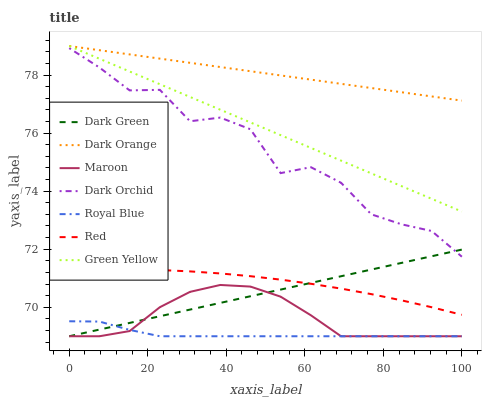Does Royal Blue have the minimum area under the curve?
Answer yes or no. Yes. Does Dark Orange have the maximum area under the curve?
Answer yes or no. Yes. Does Dark Orchid have the minimum area under the curve?
Answer yes or no. No. Does Dark Orchid have the maximum area under the curve?
Answer yes or no. No. Is Green Yellow the smoothest?
Answer yes or no. Yes. Is Dark Orchid the roughest?
Answer yes or no. Yes. Is Royal Blue the smoothest?
Answer yes or no. No. Is Royal Blue the roughest?
Answer yes or no. No. Does Royal Blue have the lowest value?
Answer yes or no. Yes. Does Dark Orchid have the lowest value?
Answer yes or no. No. Does Green Yellow have the highest value?
Answer yes or no. Yes. Does Dark Orchid have the highest value?
Answer yes or no. No. Is Dark Orchid less than Green Yellow?
Answer yes or no. Yes. Is Red greater than Royal Blue?
Answer yes or no. Yes. Does Green Yellow intersect Dark Orange?
Answer yes or no. Yes. Is Green Yellow less than Dark Orange?
Answer yes or no. No. Is Green Yellow greater than Dark Orange?
Answer yes or no. No. Does Dark Orchid intersect Green Yellow?
Answer yes or no. No. 